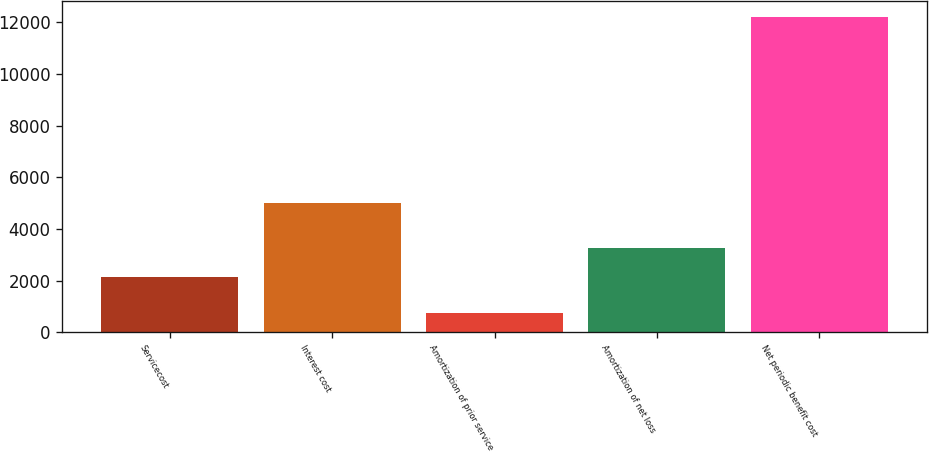<chart> <loc_0><loc_0><loc_500><loc_500><bar_chart><fcel>Servicecost<fcel>Interest cost<fcel>Amortization of prior service<fcel>Amortization of net loss<fcel>Net periodic benefit cost<nl><fcel>2119<fcel>4989<fcel>753<fcel>3264.9<fcel>12212<nl></chart> 